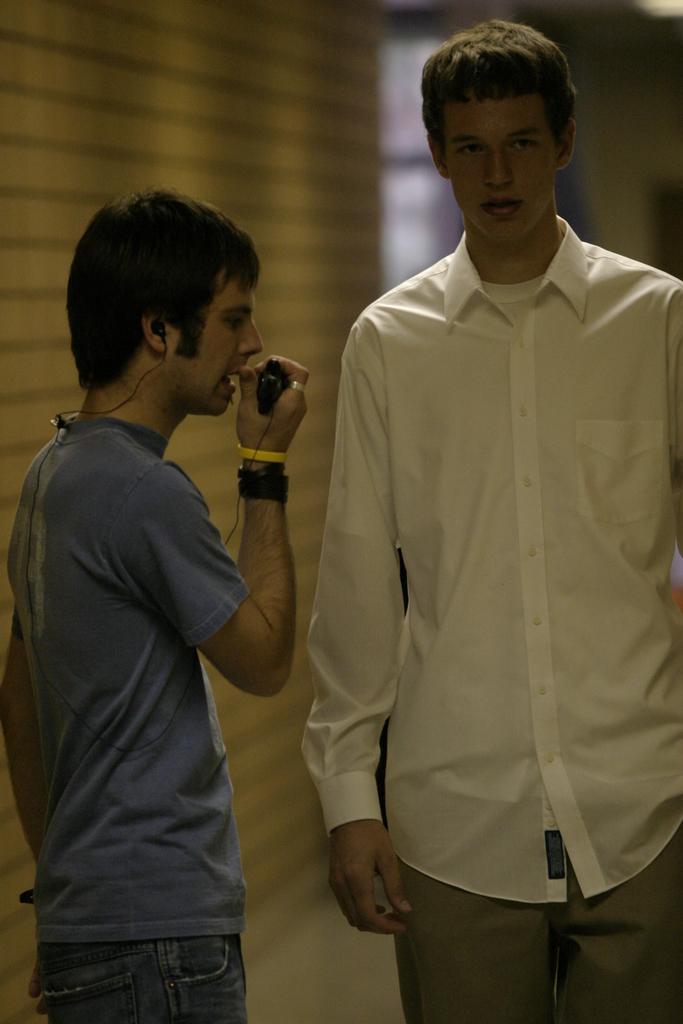Could you give a brief overview of what you see in this image? In this image I can see two men are standing. The man who is on the left side is holding an object in the hand and speaking. In the background there is a wall. 